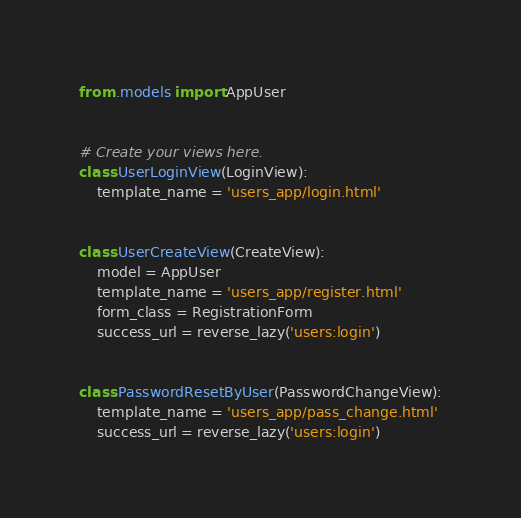<code> <loc_0><loc_0><loc_500><loc_500><_Python_>from .models import AppUser


# Create your views here.
class UserLoginView(LoginView):
    template_name = 'users_app/login.html'


class UserCreateView(CreateView):
    model = AppUser
    template_name = 'users_app/register.html'
    form_class = RegistrationForm
    success_url = reverse_lazy('users:login')


class PasswordResetByUser(PasswordChangeView):
    template_name = 'users_app/pass_change.html'
    success_url = reverse_lazy('users:login')
</code> 